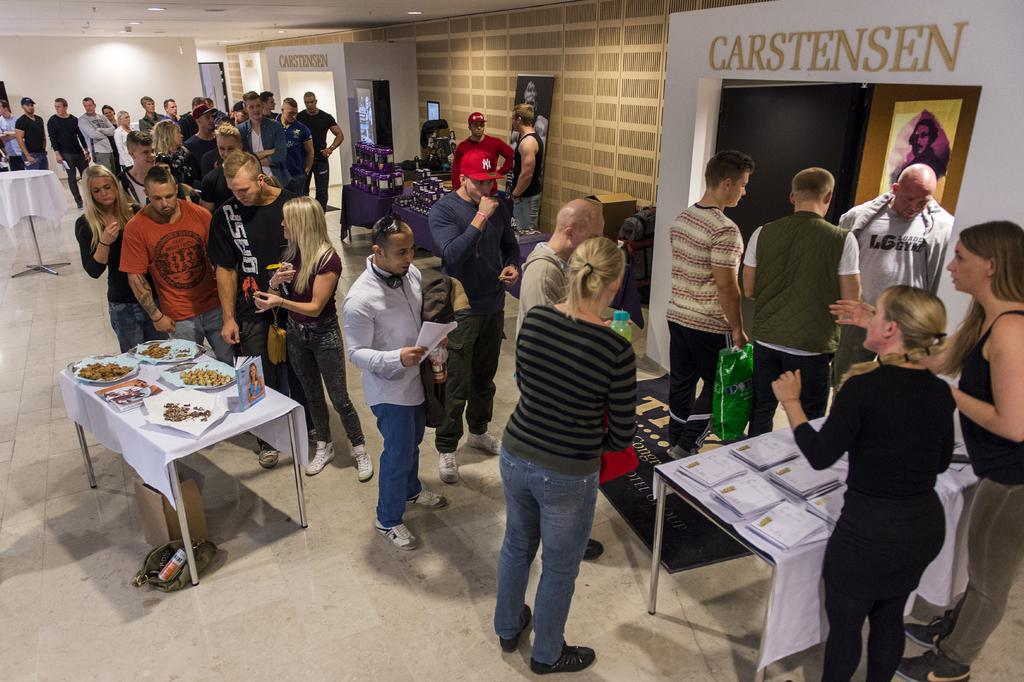What is happening in the image? There are people standing in the image. Can you describe the setting? There are multiple tables in the image, and there are many things on the tables. What can be seen in the background of the image? There is a wall in the background of the image, and there are lights on the ceiling. Are there any pests visible in the image? There is no indication of pests in the image. Can you see any dinosaurs in the image? There are no dinosaurs present in the image. 